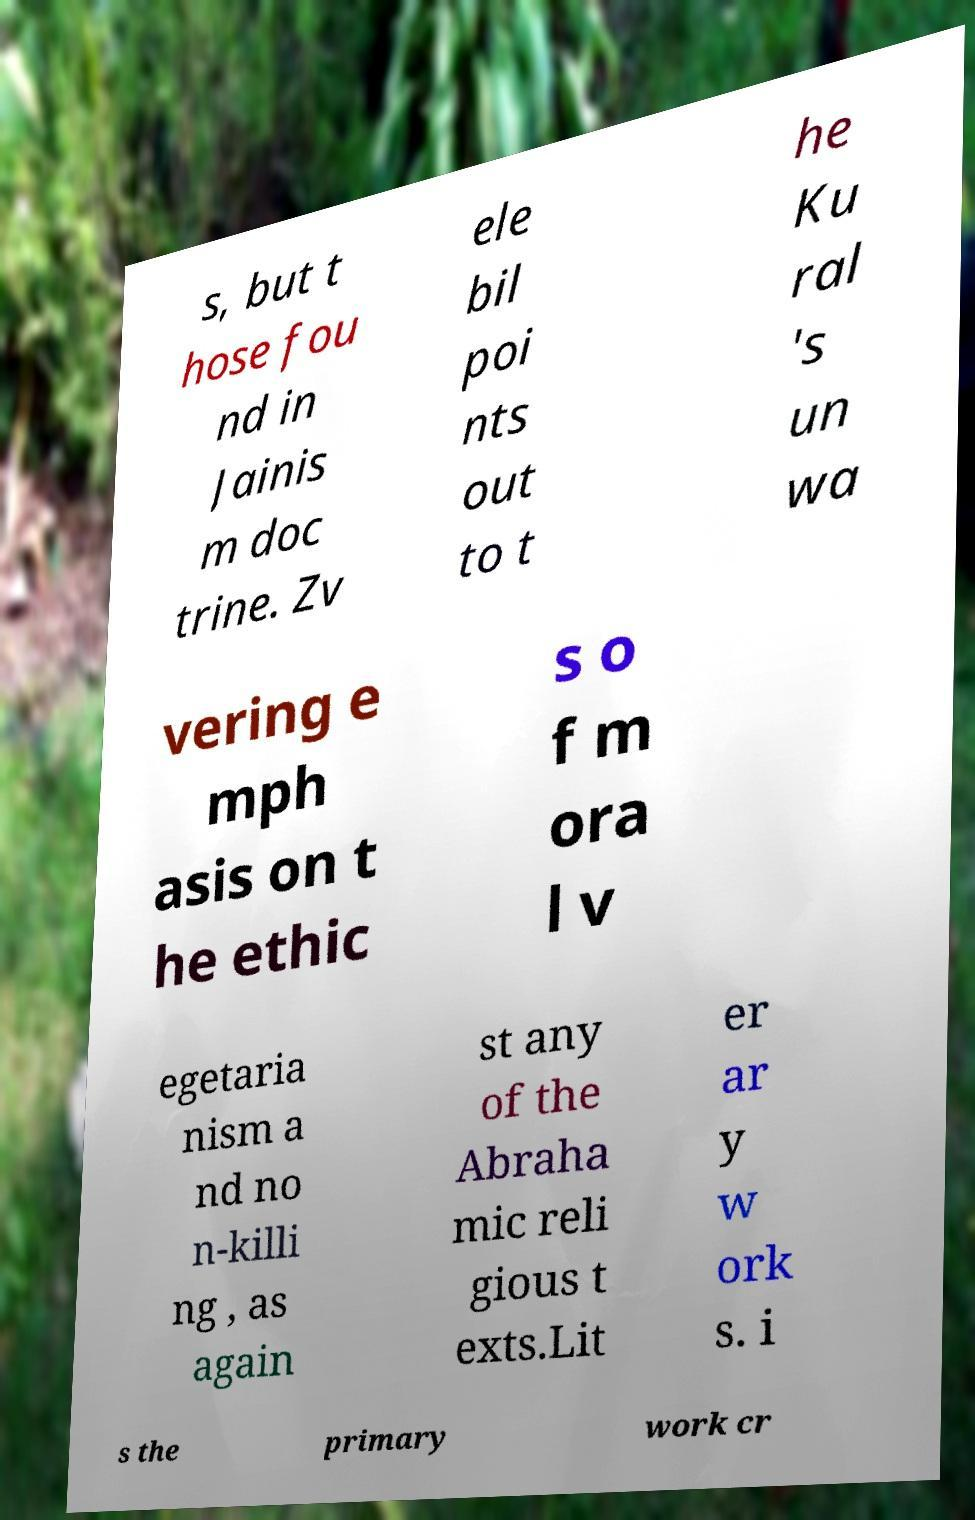What messages or text are displayed in this image? I need them in a readable, typed format. s, but t hose fou nd in Jainis m doc trine. Zv ele bil poi nts out to t he Ku ral 's un wa vering e mph asis on t he ethic s o f m ora l v egetaria nism a nd no n-killi ng , as again st any of the Abraha mic reli gious t exts.Lit er ar y w ork s. i s the primary work cr 